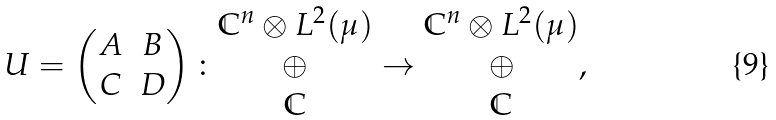Convert formula to latex. <formula><loc_0><loc_0><loc_500><loc_500>U = \begin{pmatrix} A & B \\ C & D \end{pmatrix} \colon \begin{matrix} \mathbb { C } ^ { n } \otimes L ^ { 2 } ( \mu ) \\ \oplus \\ \mathbb { C } \end{matrix} \rightarrow \begin{matrix} \mathbb { C } ^ { n } \otimes L ^ { 2 } ( \mu ) \\ \oplus \\ \mathbb { C } \end{matrix} ,</formula> 